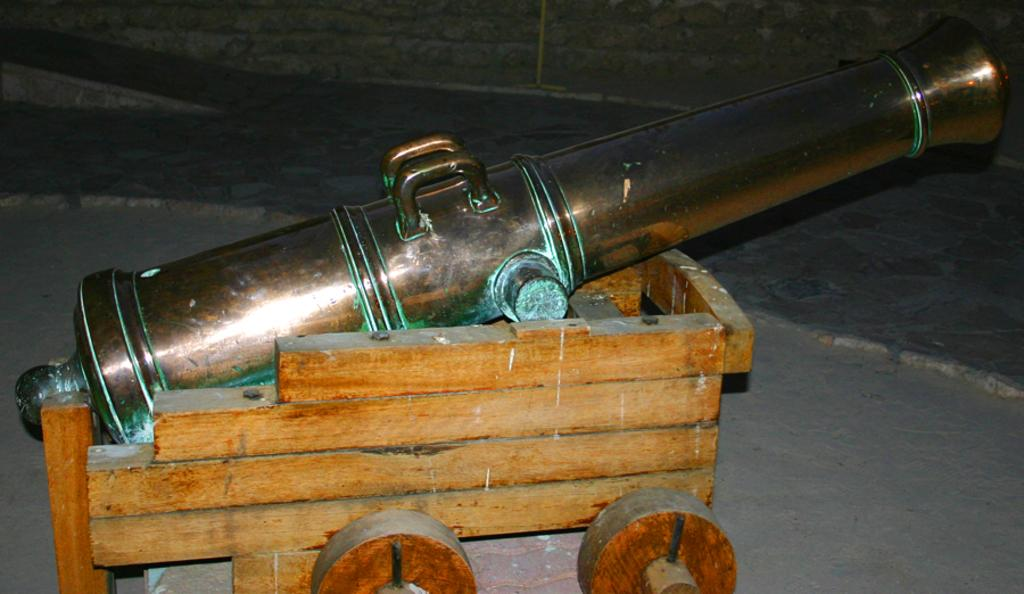What is the main subject of the image? The main subject of the image is a cannon. How is the cannon positioned in the image? The cannon is on a wooden cart. What can be seen beneath the cannon and cart in the image? The ground is visible in the image. Is there a tent in the image that is playing a rhythm? There is no tent or any indication of rhythmic activity present in the image. 